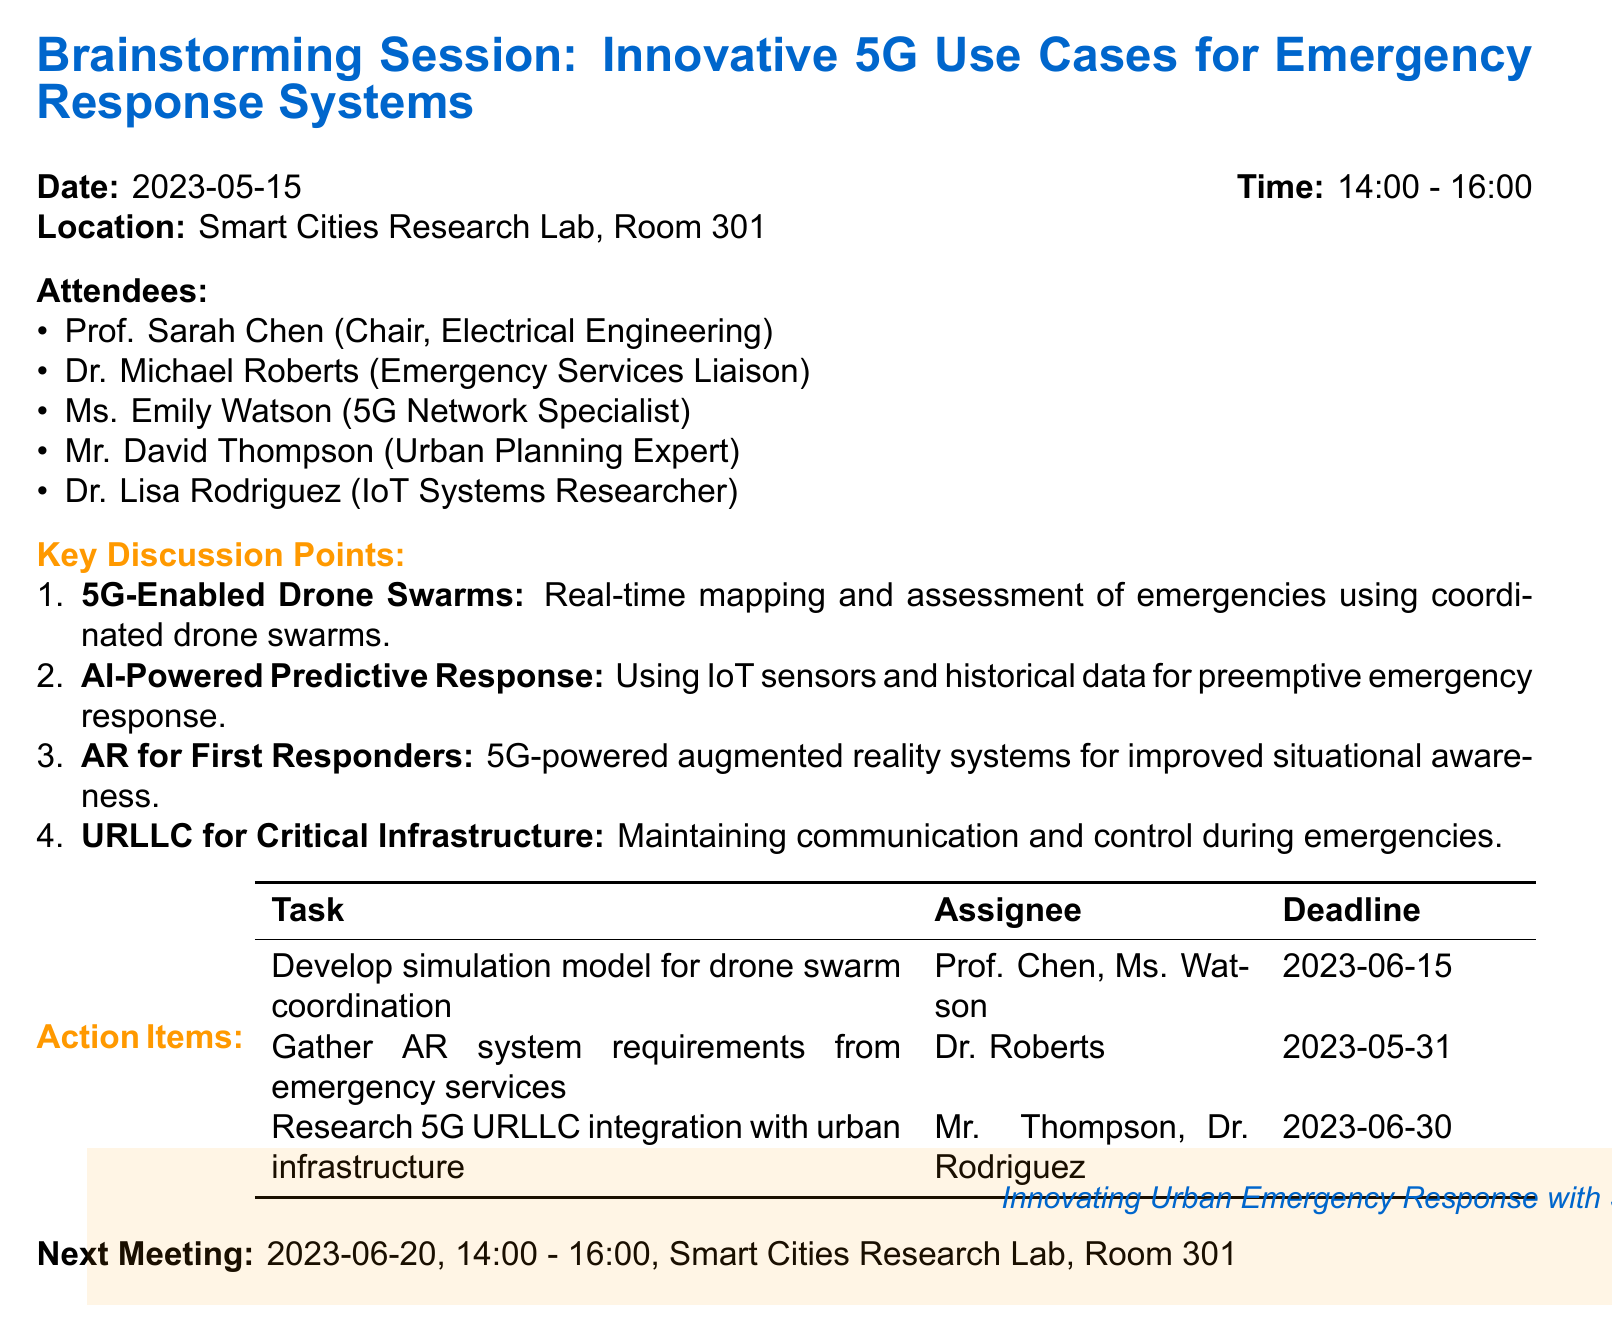What is the date of the meeting? The date is clearly stated in the meeting details section of the document.
Answer: 2023-05-15 Who is the chair of the meeting? The chairperson is mentioned in the list of attendees.
Answer: Prof. Sarah Chen What is the location of the next meeting? The location is specified under the next meeting section in the document.
Answer: Smart Cities Research Lab, Room 301 What is one innovative use case discussed for emergency response systems? The document lists key discussion points regarding innovative use cases.
Answer: 5G-Enabled Drone Swarms for Rapid Situational Assessment Who is responsible for liaising with local emergency services? The person assigned to this task is listed under the action items section.
Answer: Dr. Michael Roberts What is the deadline for developing the simulation model? The deadline for this action item is stated in the action items section.
Answer: 2023-06-15 How many key discussion points were mentioned? The total number of discussion points is indicated in the enumeration of the key discussion points.
Answer: Four Which attendee specializes in 5G networks? The attendees' expertise is outlined in their respective titles in the document.
Answer: Ms. Emily Watson What is the focus of the brainstorming session? The title of the meeting provides insight into the main focus.
Answer: Innovative 5G Use Cases for Emergency Response Systems in Urban Environments 